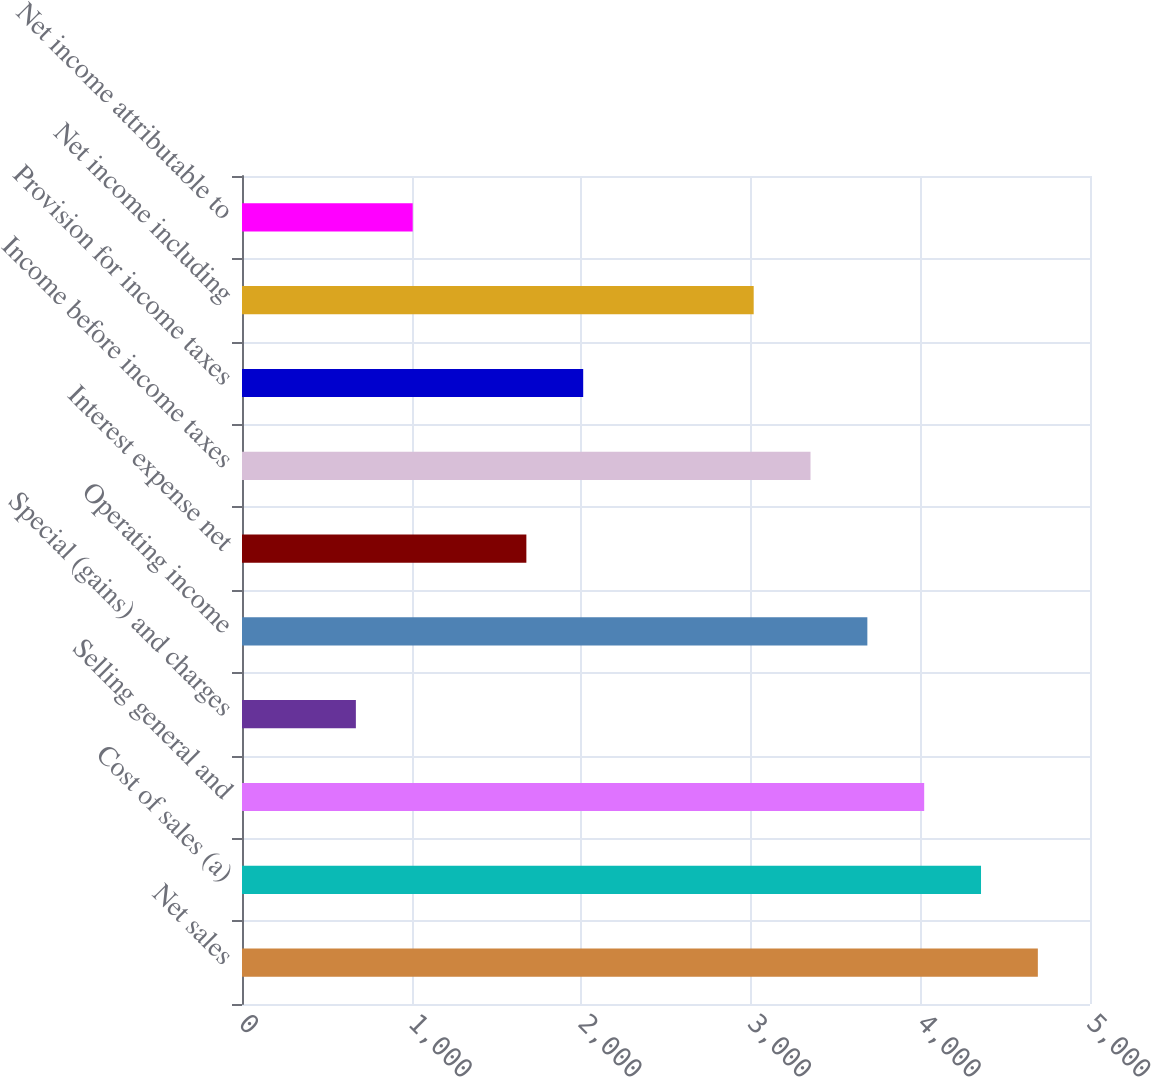<chart> <loc_0><loc_0><loc_500><loc_500><bar_chart><fcel>Net sales<fcel>Cost of sales (a)<fcel>Selling general and<fcel>Special (gains) and charges<fcel>Operating income<fcel>Interest expense net<fcel>Income before income taxes<fcel>Provision for income taxes<fcel>Net income including<fcel>Net income attributable to<nl><fcel>4692.5<fcel>4357.41<fcel>4022.32<fcel>671.42<fcel>3687.23<fcel>1676.69<fcel>3352.14<fcel>2011.78<fcel>3017.05<fcel>1006.51<nl></chart> 